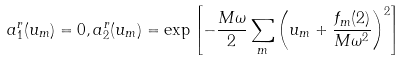Convert formula to latex. <formula><loc_0><loc_0><loc_500><loc_500>a ^ { r } _ { 1 } ( u _ { m } ) = 0 , a ^ { r } _ { 2 } ( u _ { m } ) = \exp \left [ - \frac { M \omega } { 2 } \sum _ { m } \left ( u _ { m } + \frac { f _ { m } ( { 2 } ) } { M \omega ^ { 2 } } \right ) ^ { 2 } \right ]</formula> 